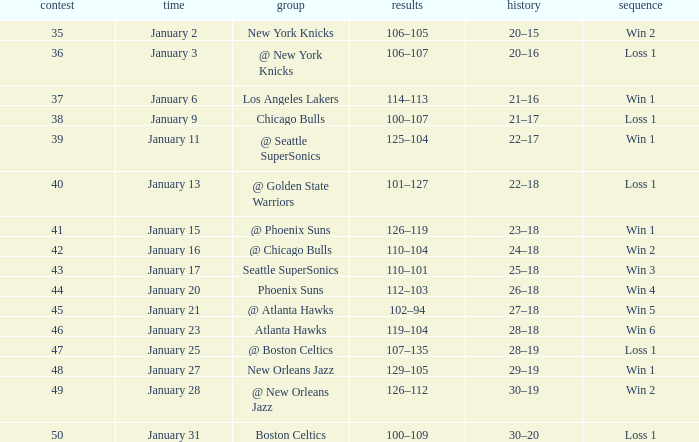What is the Streak in the game with a Record of 20–16? Loss 1. 